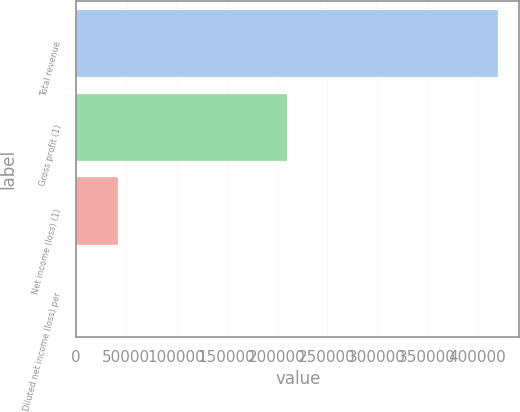Convert chart. <chart><loc_0><loc_0><loc_500><loc_500><bar_chart><fcel>Total revenue<fcel>Gross profit (1)<fcel>Net income (loss) (1)<fcel>Diluted net income (loss) per<nl><fcel>420693<fcel>209889<fcel>42069.4<fcel>0.1<nl></chart> 